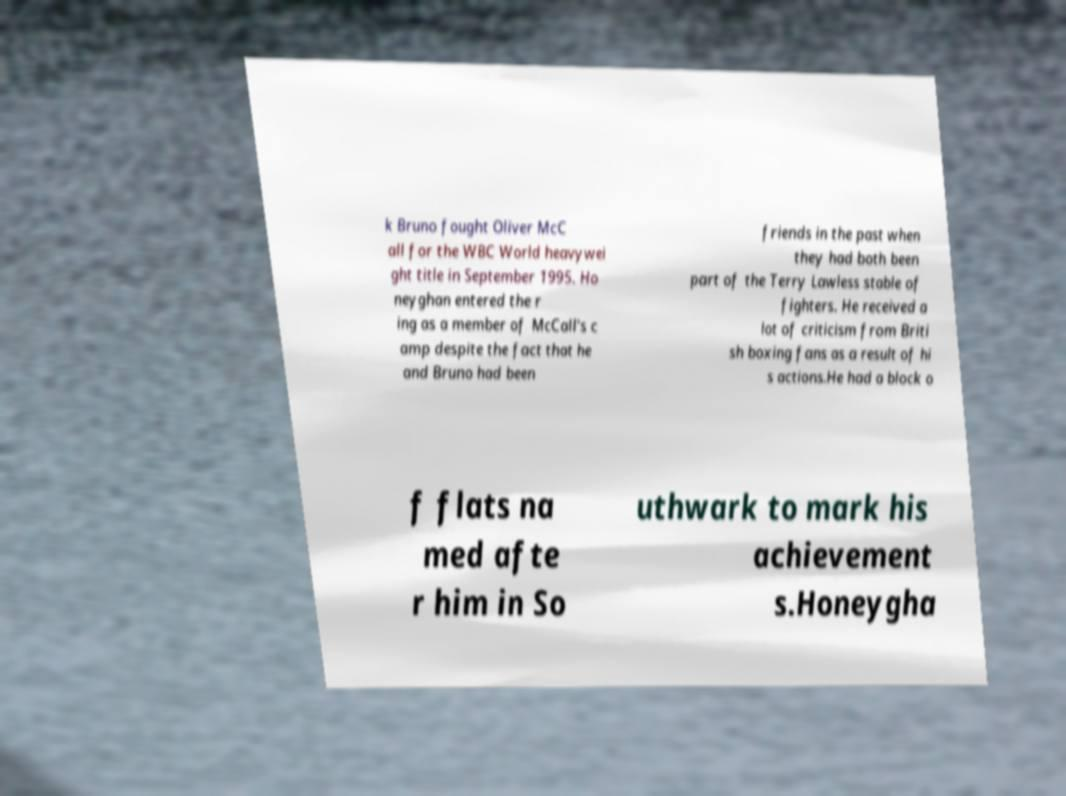What messages or text are displayed in this image? I need them in a readable, typed format. k Bruno fought Oliver McC all for the WBC World heavywei ght title in September 1995. Ho neyghan entered the r ing as a member of McCall's c amp despite the fact that he and Bruno had been friends in the past when they had both been part of the Terry Lawless stable of fighters. He received a lot of criticism from Briti sh boxing fans as a result of hi s actions.He had a block o f flats na med afte r him in So uthwark to mark his achievement s.Honeygha 